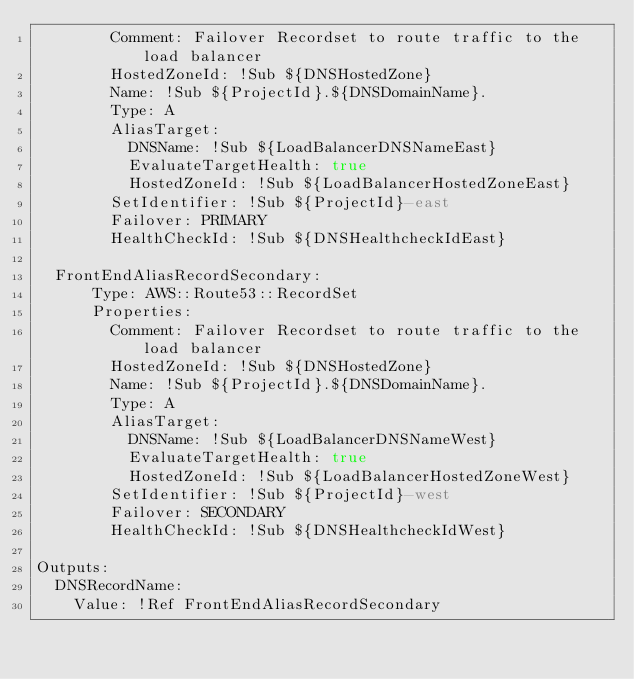<code> <loc_0><loc_0><loc_500><loc_500><_YAML_>        Comment: Failover Recordset to route traffic to the load balancer
        HostedZoneId: !Sub ${DNSHostedZone}
        Name: !Sub ${ProjectId}.${DNSDomainName}.
        Type: A
        AliasTarget:
          DNSName: !Sub ${LoadBalancerDNSNameEast}
          EvaluateTargetHealth: true
          HostedZoneId: !Sub ${LoadBalancerHostedZoneEast}
        SetIdentifier: !Sub ${ProjectId}-east 
        Failover: PRIMARY 
        HealthCheckId: !Sub ${DNSHealthcheckIdEast}

  FrontEndAliasRecordSecondary:
      Type: AWS::Route53::RecordSet
      Properties:
        Comment: Failover Recordset to route traffic to the load balancer
        HostedZoneId: !Sub ${DNSHostedZone}
        Name: !Sub ${ProjectId}.${DNSDomainName}.
        Type: A
        AliasTarget:
          DNSName: !Sub ${LoadBalancerDNSNameWest}
          EvaluateTargetHealth: true
          HostedZoneId: !Sub ${LoadBalancerHostedZoneWest}
        SetIdentifier: !Sub ${ProjectId}-west
        Failover: SECONDARY 
        HealthCheckId: !Sub ${DNSHealthcheckIdWest}

Outputs:
  DNSRecordName:
    Value: !Ref FrontEndAliasRecordSecondary
  </code> 